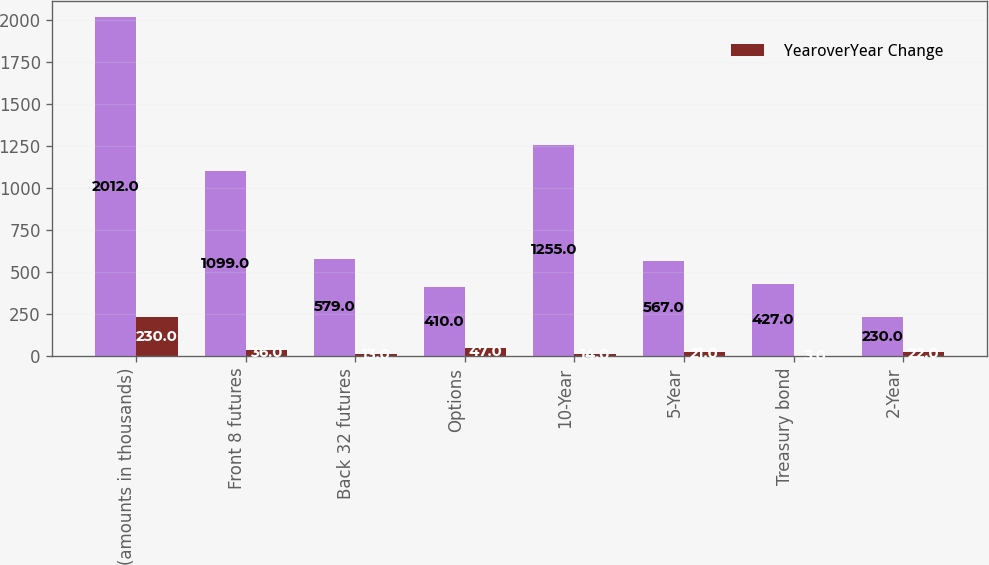<chart> <loc_0><loc_0><loc_500><loc_500><stacked_bar_chart><ecel><fcel>(amounts in thousands)<fcel>Front 8 futures<fcel>Back 32 futures<fcel>Options<fcel>10-Year<fcel>5-Year<fcel>Treasury bond<fcel>2-Year<nl><fcel>nan<fcel>2012<fcel>1099<fcel>579<fcel>410<fcel>1255<fcel>567<fcel>427<fcel>230<nl><fcel>YearoverYear Change<fcel>230<fcel>36<fcel>13<fcel>47<fcel>14<fcel>21<fcel>3<fcel>22<nl></chart> 